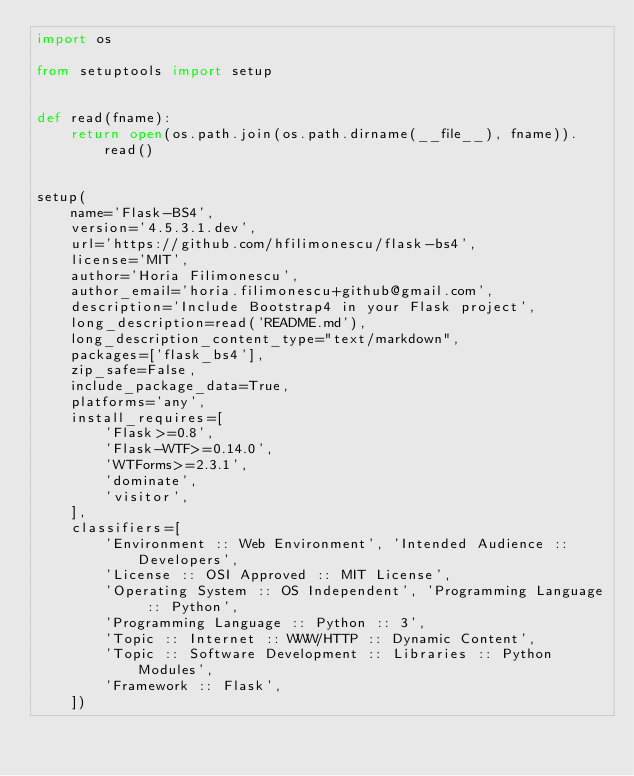Convert code to text. <code><loc_0><loc_0><loc_500><loc_500><_Python_>import os

from setuptools import setup


def read(fname):
    return open(os.path.join(os.path.dirname(__file__), fname)).read()


setup(
    name='Flask-BS4',
    version='4.5.3.1.dev',
    url='https://github.com/hfilimonescu/flask-bs4',
    license='MIT',
    author='Horia Filimonescu',
    author_email='horia.filimonescu+github@gmail.com',
    description='Include Bootstrap4 in your Flask project',
    long_description=read('README.md'),
    long_description_content_type="text/markdown",
    packages=['flask_bs4'],
    zip_safe=False,
    include_package_data=True,
    platforms='any',
    install_requires=[
        'Flask>=0.8',
        'Flask-WTF>=0.14.0',
        'WTForms>=2.3.1',
        'dominate',
        'visitor',
    ],
    classifiers=[
        'Environment :: Web Environment', 'Intended Audience :: Developers',
        'License :: OSI Approved :: MIT License',
        'Operating System :: OS Independent', 'Programming Language :: Python',
        'Programming Language :: Python :: 3',
        'Topic :: Internet :: WWW/HTTP :: Dynamic Content',
        'Topic :: Software Development :: Libraries :: Python Modules',
        'Framework :: Flask',
    ])
</code> 